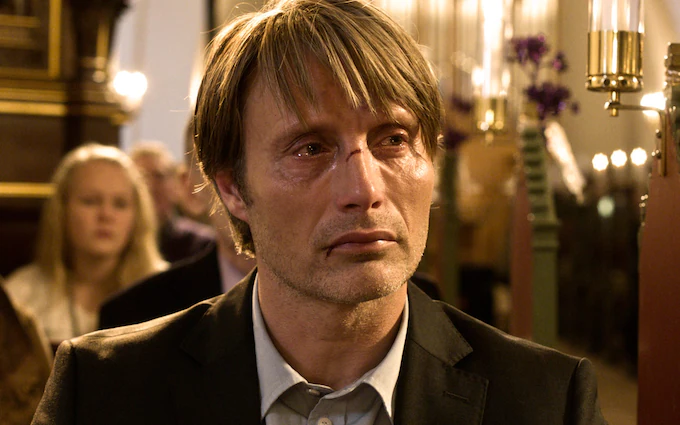What emotions do you believe the man in the image is experiencing? The man in the image appears to be experiencing deep sorrow or contemplation. His tear-filled eyes and the solemn expression on his face suggest that he is going through an emotionally challenging moment. The setting of the church might also imply that he is reflecting on something significant, perhaps a loss or a deeply personal revelation. 